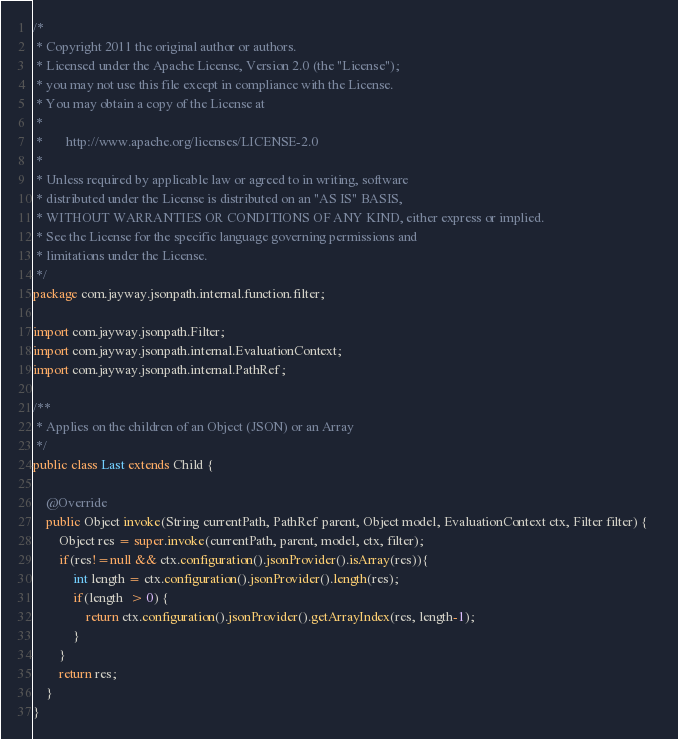<code> <loc_0><loc_0><loc_500><loc_500><_Java_>/*
 * Copyright 2011 the original author or authors.
 * Licensed under the Apache License, Version 2.0 (the "License");
 * you may not use this file except in compliance with the License.
 * You may obtain a copy of the License at
 *
 *       http://www.apache.org/licenses/LICENSE-2.0
 *
 * Unless required by applicable law or agreed to in writing, software
 * distributed under the License is distributed on an "AS IS" BASIS,
 * WITHOUT WARRANTIES OR CONDITIONS OF ANY KIND, either express or implied.
 * See the License for the specific language governing permissions and
 * limitations under the License.
 */
package com.jayway.jsonpath.internal.function.filter;

import com.jayway.jsonpath.Filter;
import com.jayway.jsonpath.internal.EvaluationContext;
import com.jayway.jsonpath.internal.PathRef;

/**
 * Applies on the children of an Object (JSON) or an Array
 */ 
public class Last extends Child {

    @Override
    public Object invoke(String currentPath, PathRef parent, Object model, EvaluationContext ctx, Filter filter) {   	
    	Object res = super.invoke(currentPath, parent, model, ctx, filter);
    	if(res!=null && ctx.configuration().jsonProvider().isArray(res)){	
    		int length = ctx.configuration().jsonProvider().length(res);
            if(length  > 0) {
            	return ctx.configuration().jsonProvider().getArrayIndex(res, length-1);
            }
    	}	
    	return res;		
    }
}
</code> 